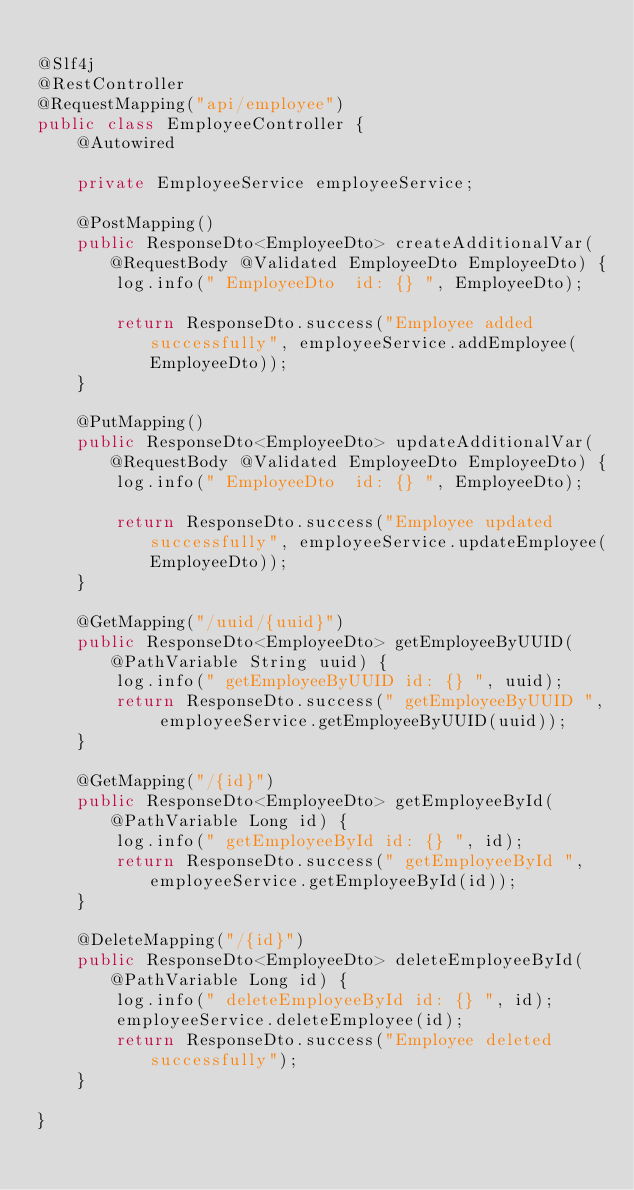Convert code to text. <code><loc_0><loc_0><loc_500><loc_500><_Java_>
@Slf4j
@RestController
@RequestMapping("api/employee")
public class EmployeeController {
	@Autowired

	private EmployeeService employeeService;

	@PostMapping()
	public ResponseDto<EmployeeDto> createAdditionalVar(@RequestBody @Validated EmployeeDto EmployeeDto) {
		log.info(" EmployeeDto  id: {} ", EmployeeDto);

		return ResponseDto.success("Employee added successfully", employeeService.addEmployee(EmployeeDto));
	}

	@PutMapping()
	public ResponseDto<EmployeeDto> updateAdditionalVar(@RequestBody @Validated EmployeeDto EmployeeDto) {
		log.info(" EmployeeDto  id: {} ", EmployeeDto);

		return ResponseDto.success("Employee updated successfully", employeeService.updateEmployee(EmployeeDto));
	}

	@GetMapping("/uuid/{uuid}")
	public ResponseDto<EmployeeDto> getEmployeeByUUID(@PathVariable String uuid) {
		log.info(" getEmployeeByUUID id: {} ", uuid);
		return ResponseDto.success(" getEmployeeByUUID ", employeeService.getEmployeeByUUID(uuid));
	}

	@GetMapping("/{id}")
	public ResponseDto<EmployeeDto> getEmployeeById(@PathVariable Long id) {
		log.info(" getEmployeeById id: {} ", id);
		return ResponseDto.success(" getEmployeeById ", employeeService.getEmployeeById(id));
	}

	@DeleteMapping("/{id}")
	public ResponseDto<EmployeeDto> deleteEmployeeById(@PathVariable Long id) {
		log.info(" deleteEmployeeById id: {} ", id);
		employeeService.deleteEmployee(id);
		return ResponseDto.success("Employee deleted successfully");
	}

}</code> 